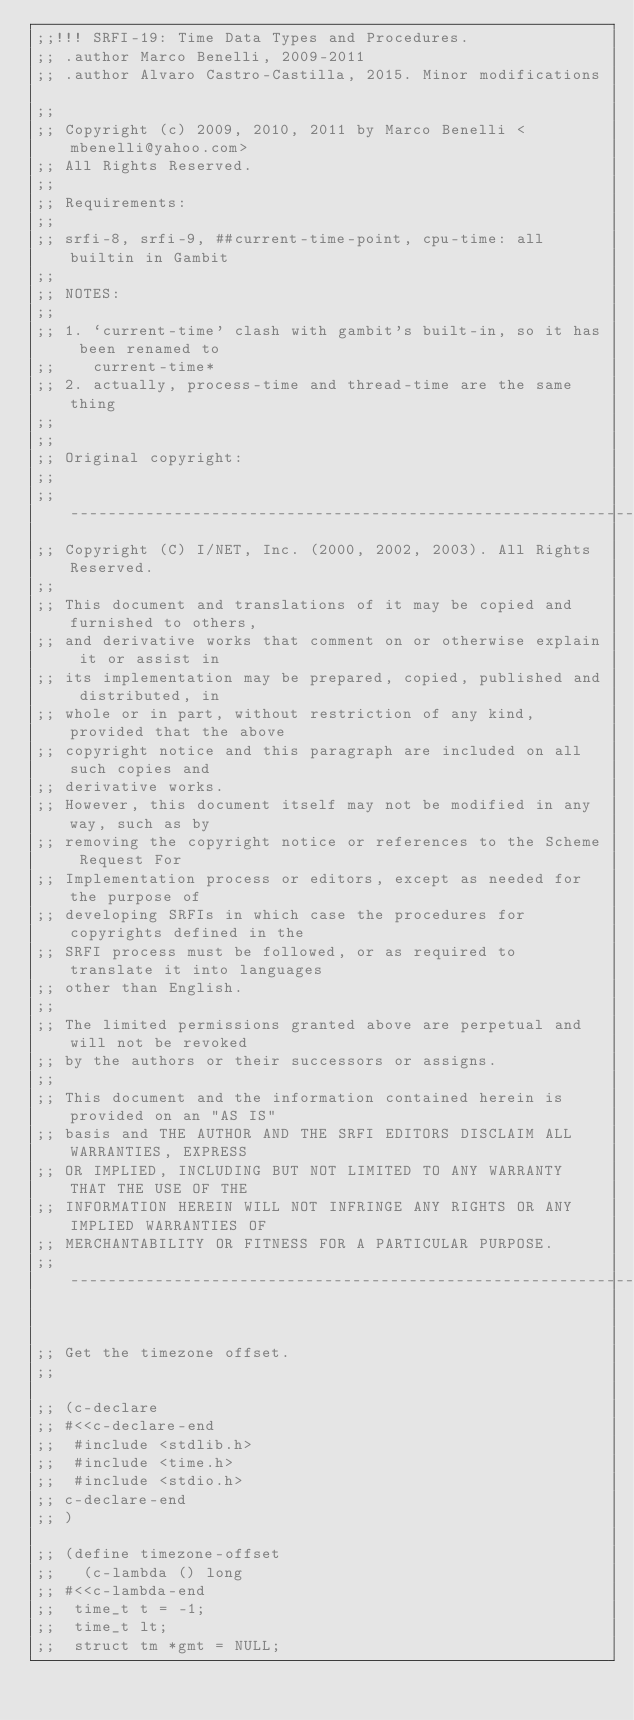<code> <loc_0><loc_0><loc_500><loc_500><_Scheme_>;;!!! SRFI-19: Time Data Types and Procedures.
;; .author Marco Benelli, 2009-2011
;; .author Alvaro Castro-Castilla, 2015. Minor modifications

;;
;; Copyright (c) 2009, 2010, 2011 by Marco Benelli <mbenelli@yahoo.com>
;; All Rights Reserved.
;;
;; Requirements:
;;
;; srfi-8, srfi-9, ##current-time-point, cpu-time: all builtin in Gambit
;;
;; NOTES:
;;
;; 1. `current-time' clash with gambit's built-in, so it has been renamed to
;;    current-time*
;; 2. actually, process-time and thread-time are the same thing
;;
;;
;; Original copyright:
;;
;; ----------------------------------------------------------------------------
;; Copyright (C) I/NET, Inc. (2000, 2002, 2003). All Rights Reserved.
;;
;; This document and translations of it may be copied and furnished to others,
;; and derivative works that comment on or otherwise explain it or assist in
;; its implementation may be prepared, copied, published and distributed, in
;; whole or in part, without restriction of any kind, provided that the above
;; copyright notice and this paragraph are included on all such copies and
;; derivative works.
;; However, this document itself may not be modified in any way, such as by
;; removing the copyright notice or references to the Scheme Request For
;; Implementation process or editors, except as needed for the purpose of
;; developing SRFIs in which case the procedures for copyrights defined in the
;; SRFI process must be followed, or as required to translate it into languages
;; other than English.
;;
;; The limited permissions granted above are perpetual and will not be revoked
;; by the authors or their successors or assigns.
;;
;; This document and the information contained herein is provided on an "AS IS"
;; basis and THE AUTHOR AND THE SRFI EDITORS DISCLAIM ALL WARRANTIES, EXPRESS
;; OR IMPLIED, INCLUDING BUT NOT LIMITED TO ANY WARRANTY THAT THE USE OF THE
;; INFORMATION HEREIN WILL NOT INFRINGE ANY RIGHTS OR ANY IMPLIED WARRANTIES OF
;; MERCHANTABILITY OR FITNESS FOR A PARTICULAR PURPOSE.
;; ----------------------------------------------------------------------------


;; Get the timezone offset.
;;

;; (c-declare
;; #<<c-declare-end
;; 	#include <stdlib.h>
;; 	#include <time.h>
;; 	#include <stdio.h>
;; c-declare-end
;; )

;; (define timezone-offset
;;   (c-lambda () long
;; #<<c-lambda-end
;; 	time_t t = -1;
;; 	time_t lt;
;; 	struct tm *gmt = NULL;</code> 